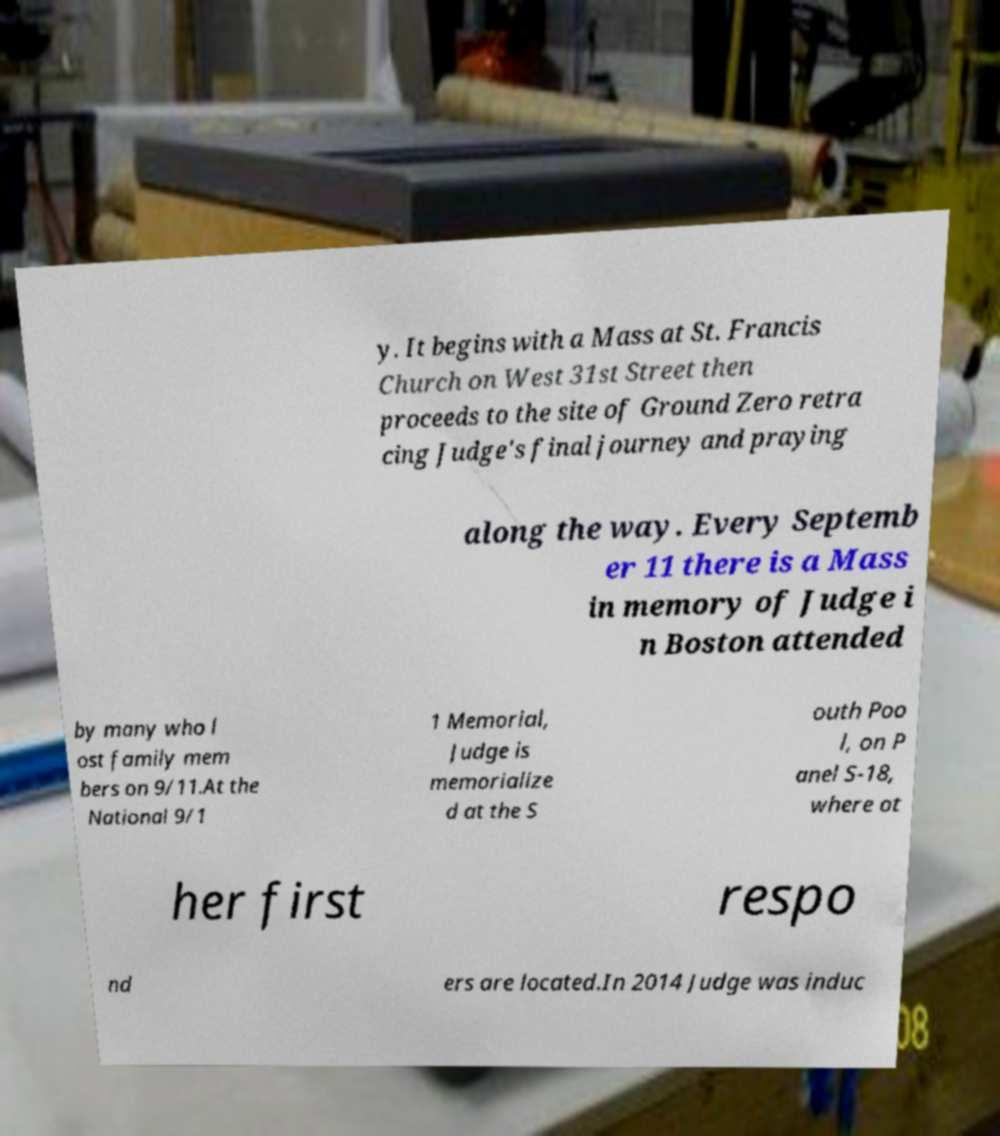There's text embedded in this image that I need extracted. Can you transcribe it verbatim? y. It begins with a Mass at St. Francis Church on West 31st Street then proceeds to the site of Ground Zero retra cing Judge's final journey and praying along the way. Every Septemb er 11 there is a Mass in memory of Judge i n Boston attended by many who l ost family mem bers on 9/11.At the National 9/1 1 Memorial, Judge is memorialize d at the S outh Poo l, on P anel S-18, where ot her first respo nd ers are located.In 2014 Judge was induc 